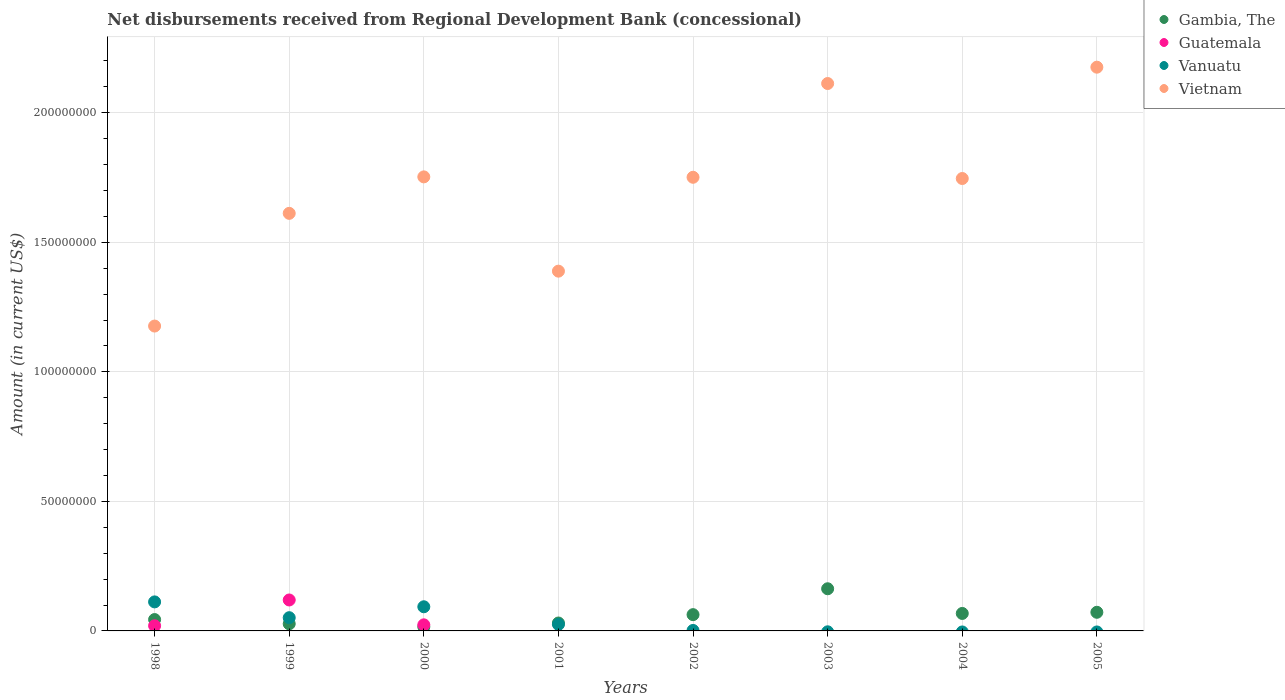What is the amount of disbursements received from Regional Development Bank in Vietnam in 1998?
Provide a short and direct response. 1.18e+08. Across all years, what is the maximum amount of disbursements received from Regional Development Bank in Gambia, The?
Your response must be concise. 1.63e+07. In which year was the amount of disbursements received from Regional Development Bank in Vietnam maximum?
Ensure brevity in your answer.  2005. What is the total amount of disbursements received from Regional Development Bank in Gambia, The in the graph?
Offer a very short reply. 4.83e+07. What is the difference between the amount of disbursements received from Regional Development Bank in Vietnam in 1998 and that in 2003?
Your answer should be very brief. -9.36e+07. What is the difference between the amount of disbursements received from Regional Development Bank in Vietnam in 2003 and the amount of disbursements received from Regional Development Bank in Guatemala in 1999?
Give a very brief answer. 1.99e+08. What is the average amount of disbursements received from Regional Development Bank in Vanuatu per year?
Your answer should be very brief. 3.54e+06. In the year 1999, what is the difference between the amount of disbursements received from Regional Development Bank in Vanuatu and amount of disbursements received from Regional Development Bank in Vietnam?
Ensure brevity in your answer.  -1.56e+08. In how many years, is the amount of disbursements received from Regional Development Bank in Vietnam greater than 160000000 US$?
Your answer should be compact. 6. What is the ratio of the amount of disbursements received from Regional Development Bank in Gambia, The in 2000 to that in 2003?
Your response must be concise. 0.1. Is the difference between the amount of disbursements received from Regional Development Bank in Vanuatu in 1998 and 1999 greater than the difference between the amount of disbursements received from Regional Development Bank in Vietnam in 1998 and 1999?
Your answer should be very brief. Yes. What is the difference between the highest and the second highest amount of disbursements received from Regional Development Bank in Vietnam?
Offer a terse response. 6.31e+06. What is the difference between the highest and the lowest amount of disbursements received from Regional Development Bank in Guatemala?
Your answer should be compact. 1.19e+07. In how many years, is the amount of disbursements received from Regional Development Bank in Vanuatu greater than the average amount of disbursements received from Regional Development Bank in Vanuatu taken over all years?
Your answer should be compact. 3. Is the amount of disbursements received from Regional Development Bank in Guatemala strictly greater than the amount of disbursements received from Regional Development Bank in Gambia, The over the years?
Give a very brief answer. No. How many dotlines are there?
Your answer should be very brief. 4. Are the values on the major ticks of Y-axis written in scientific E-notation?
Provide a short and direct response. No. Where does the legend appear in the graph?
Ensure brevity in your answer.  Top right. How many legend labels are there?
Your answer should be compact. 4. What is the title of the graph?
Your response must be concise. Net disbursements received from Regional Development Bank (concessional). Does "New Caledonia" appear as one of the legend labels in the graph?
Provide a succinct answer. No. What is the label or title of the X-axis?
Give a very brief answer. Years. What is the Amount (in current US$) in Gambia, The in 1998?
Keep it short and to the point. 4.39e+06. What is the Amount (in current US$) of Guatemala in 1998?
Your answer should be compact. 1.99e+06. What is the Amount (in current US$) in Vanuatu in 1998?
Keep it short and to the point. 1.12e+07. What is the Amount (in current US$) of Vietnam in 1998?
Your answer should be very brief. 1.18e+08. What is the Amount (in current US$) of Gambia, The in 1999?
Your answer should be very brief. 2.75e+06. What is the Amount (in current US$) in Guatemala in 1999?
Keep it short and to the point. 1.19e+07. What is the Amount (in current US$) of Vanuatu in 1999?
Provide a succinct answer. 5.10e+06. What is the Amount (in current US$) of Vietnam in 1999?
Ensure brevity in your answer.  1.61e+08. What is the Amount (in current US$) of Gambia, The in 2000?
Keep it short and to the point. 1.57e+06. What is the Amount (in current US$) of Guatemala in 2000?
Provide a short and direct response. 2.35e+06. What is the Amount (in current US$) in Vanuatu in 2000?
Offer a terse response. 9.32e+06. What is the Amount (in current US$) in Vietnam in 2000?
Provide a succinct answer. 1.75e+08. What is the Amount (in current US$) in Gambia, The in 2001?
Offer a terse response. 3.06e+06. What is the Amount (in current US$) of Vanuatu in 2001?
Offer a very short reply. 2.52e+06. What is the Amount (in current US$) in Vietnam in 2001?
Offer a very short reply. 1.39e+08. What is the Amount (in current US$) in Gambia, The in 2002?
Offer a very short reply. 6.28e+06. What is the Amount (in current US$) of Guatemala in 2002?
Offer a very short reply. 0. What is the Amount (in current US$) of Vanuatu in 2002?
Provide a succinct answer. 1.81e+05. What is the Amount (in current US$) in Vietnam in 2002?
Your response must be concise. 1.75e+08. What is the Amount (in current US$) in Gambia, The in 2003?
Your answer should be very brief. 1.63e+07. What is the Amount (in current US$) of Guatemala in 2003?
Provide a short and direct response. 0. What is the Amount (in current US$) in Vietnam in 2003?
Offer a terse response. 2.11e+08. What is the Amount (in current US$) of Gambia, The in 2004?
Give a very brief answer. 6.75e+06. What is the Amount (in current US$) in Vanuatu in 2004?
Your answer should be very brief. 0. What is the Amount (in current US$) of Vietnam in 2004?
Offer a terse response. 1.75e+08. What is the Amount (in current US$) in Gambia, The in 2005?
Offer a terse response. 7.19e+06. What is the Amount (in current US$) of Vanuatu in 2005?
Your answer should be very brief. 0. What is the Amount (in current US$) of Vietnam in 2005?
Your answer should be very brief. 2.18e+08. Across all years, what is the maximum Amount (in current US$) in Gambia, The?
Offer a very short reply. 1.63e+07. Across all years, what is the maximum Amount (in current US$) in Guatemala?
Your answer should be very brief. 1.19e+07. Across all years, what is the maximum Amount (in current US$) of Vanuatu?
Keep it short and to the point. 1.12e+07. Across all years, what is the maximum Amount (in current US$) in Vietnam?
Your response must be concise. 2.18e+08. Across all years, what is the minimum Amount (in current US$) of Gambia, The?
Provide a short and direct response. 1.57e+06. Across all years, what is the minimum Amount (in current US$) of Guatemala?
Keep it short and to the point. 0. Across all years, what is the minimum Amount (in current US$) in Vanuatu?
Keep it short and to the point. 0. Across all years, what is the minimum Amount (in current US$) of Vietnam?
Offer a terse response. 1.18e+08. What is the total Amount (in current US$) of Gambia, The in the graph?
Your answer should be very brief. 4.83e+07. What is the total Amount (in current US$) of Guatemala in the graph?
Give a very brief answer. 1.63e+07. What is the total Amount (in current US$) of Vanuatu in the graph?
Offer a terse response. 2.83e+07. What is the total Amount (in current US$) in Vietnam in the graph?
Ensure brevity in your answer.  1.37e+09. What is the difference between the Amount (in current US$) of Gambia, The in 1998 and that in 1999?
Offer a very short reply. 1.64e+06. What is the difference between the Amount (in current US$) of Guatemala in 1998 and that in 1999?
Provide a succinct answer. -9.95e+06. What is the difference between the Amount (in current US$) in Vanuatu in 1998 and that in 1999?
Offer a very short reply. 6.10e+06. What is the difference between the Amount (in current US$) in Vietnam in 1998 and that in 1999?
Offer a very short reply. -4.35e+07. What is the difference between the Amount (in current US$) of Gambia, The in 1998 and that in 2000?
Give a very brief answer. 2.82e+06. What is the difference between the Amount (in current US$) in Guatemala in 1998 and that in 2000?
Make the answer very short. -3.56e+05. What is the difference between the Amount (in current US$) of Vanuatu in 1998 and that in 2000?
Provide a succinct answer. 1.88e+06. What is the difference between the Amount (in current US$) of Vietnam in 1998 and that in 2000?
Provide a short and direct response. -5.76e+07. What is the difference between the Amount (in current US$) of Gambia, The in 1998 and that in 2001?
Provide a short and direct response. 1.33e+06. What is the difference between the Amount (in current US$) in Vanuatu in 1998 and that in 2001?
Your response must be concise. 8.68e+06. What is the difference between the Amount (in current US$) in Vietnam in 1998 and that in 2001?
Give a very brief answer. -2.12e+07. What is the difference between the Amount (in current US$) of Gambia, The in 1998 and that in 2002?
Offer a very short reply. -1.89e+06. What is the difference between the Amount (in current US$) in Vanuatu in 1998 and that in 2002?
Your answer should be very brief. 1.10e+07. What is the difference between the Amount (in current US$) in Vietnam in 1998 and that in 2002?
Provide a succinct answer. -5.74e+07. What is the difference between the Amount (in current US$) of Gambia, The in 1998 and that in 2003?
Keep it short and to the point. -1.19e+07. What is the difference between the Amount (in current US$) of Vietnam in 1998 and that in 2003?
Offer a very short reply. -9.36e+07. What is the difference between the Amount (in current US$) of Gambia, The in 1998 and that in 2004?
Your answer should be compact. -2.36e+06. What is the difference between the Amount (in current US$) in Vietnam in 1998 and that in 2004?
Your response must be concise. -5.70e+07. What is the difference between the Amount (in current US$) of Gambia, The in 1998 and that in 2005?
Make the answer very short. -2.80e+06. What is the difference between the Amount (in current US$) in Vietnam in 1998 and that in 2005?
Offer a terse response. -9.99e+07. What is the difference between the Amount (in current US$) of Gambia, The in 1999 and that in 2000?
Provide a succinct answer. 1.18e+06. What is the difference between the Amount (in current US$) in Guatemala in 1999 and that in 2000?
Your response must be concise. 9.60e+06. What is the difference between the Amount (in current US$) of Vanuatu in 1999 and that in 2000?
Give a very brief answer. -4.22e+06. What is the difference between the Amount (in current US$) in Vietnam in 1999 and that in 2000?
Provide a succinct answer. -1.41e+07. What is the difference between the Amount (in current US$) of Gambia, The in 1999 and that in 2001?
Make the answer very short. -3.10e+05. What is the difference between the Amount (in current US$) in Vanuatu in 1999 and that in 2001?
Keep it short and to the point. 2.58e+06. What is the difference between the Amount (in current US$) of Vietnam in 1999 and that in 2001?
Make the answer very short. 2.23e+07. What is the difference between the Amount (in current US$) in Gambia, The in 1999 and that in 2002?
Your answer should be very brief. -3.54e+06. What is the difference between the Amount (in current US$) of Vanuatu in 1999 and that in 2002?
Offer a terse response. 4.92e+06. What is the difference between the Amount (in current US$) in Vietnam in 1999 and that in 2002?
Your answer should be compact. -1.39e+07. What is the difference between the Amount (in current US$) in Gambia, The in 1999 and that in 2003?
Give a very brief answer. -1.35e+07. What is the difference between the Amount (in current US$) of Vietnam in 1999 and that in 2003?
Your answer should be very brief. -5.01e+07. What is the difference between the Amount (in current US$) of Gambia, The in 1999 and that in 2004?
Provide a succinct answer. -4.00e+06. What is the difference between the Amount (in current US$) in Vietnam in 1999 and that in 2004?
Provide a succinct answer. -1.34e+07. What is the difference between the Amount (in current US$) in Gambia, The in 1999 and that in 2005?
Keep it short and to the point. -4.45e+06. What is the difference between the Amount (in current US$) in Vietnam in 1999 and that in 2005?
Provide a succinct answer. -5.64e+07. What is the difference between the Amount (in current US$) of Gambia, The in 2000 and that in 2001?
Offer a very short reply. -1.48e+06. What is the difference between the Amount (in current US$) in Vanuatu in 2000 and that in 2001?
Make the answer very short. 6.80e+06. What is the difference between the Amount (in current US$) in Vietnam in 2000 and that in 2001?
Your answer should be very brief. 3.64e+07. What is the difference between the Amount (in current US$) of Gambia, The in 2000 and that in 2002?
Make the answer very short. -4.71e+06. What is the difference between the Amount (in current US$) in Vanuatu in 2000 and that in 2002?
Make the answer very short. 9.14e+06. What is the difference between the Amount (in current US$) of Vietnam in 2000 and that in 2002?
Make the answer very short. 1.56e+05. What is the difference between the Amount (in current US$) in Gambia, The in 2000 and that in 2003?
Make the answer very short. -1.47e+07. What is the difference between the Amount (in current US$) of Vietnam in 2000 and that in 2003?
Your answer should be compact. -3.60e+07. What is the difference between the Amount (in current US$) of Gambia, The in 2000 and that in 2004?
Offer a very short reply. -5.18e+06. What is the difference between the Amount (in current US$) in Vietnam in 2000 and that in 2004?
Offer a very short reply. 6.31e+05. What is the difference between the Amount (in current US$) of Gambia, The in 2000 and that in 2005?
Give a very brief answer. -5.62e+06. What is the difference between the Amount (in current US$) in Vietnam in 2000 and that in 2005?
Offer a terse response. -4.23e+07. What is the difference between the Amount (in current US$) in Gambia, The in 2001 and that in 2002?
Make the answer very short. -3.22e+06. What is the difference between the Amount (in current US$) in Vanuatu in 2001 and that in 2002?
Your response must be concise. 2.34e+06. What is the difference between the Amount (in current US$) in Vietnam in 2001 and that in 2002?
Make the answer very short. -3.62e+07. What is the difference between the Amount (in current US$) of Gambia, The in 2001 and that in 2003?
Ensure brevity in your answer.  -1.32e+07. What is the difference between the Amount (in current US$) in Vietnam in 2001 and that in 2003?
Make the answer very short. -7.24e+07. What is the difference between the Amount (in current US$) of Gambia, The in 2001 and that in 2004?
Your response must be concise. -3.69e+06. What is the difference between the Amount (in current US$) of Vietnam in 2001 and that in 2004?
Your answer should be compact. -3.58e+07. What is the difference between the Amount (in current US$) of Gambia, The in 2001 and that in 2005?
Offer a terse response. -4.14e+06. What is the difference between the Amount (in current US$) in Vietnam in 2001 and that in 2005?
Provide a succinct answer. -7.87e+07. What is the difference between the Amount (in current US$) in Gambia, The in 2002 and that in 2003?
Your response must be concise. -9.99e+06. What is the difference between the Amount (in current US$) of Vietnam in 2002 and that in 2003?
Provide a succinct answer. -3.62e+07. What is the difference between the Amount (in current US$) in Gambia, The in 2002 and that in 2004?
Keep it short and to the point. -4.66e+05. What is the difference between the Amount (in current US$) in Vietnam in 2002 and that in 2004?
Make the answer very short. 4.75e+05. What is the difference between the Amount (in current US$) in Gambia, The in 2002 and that in 2005?
Your answer should be compact. -9.11e+05. What is the difference between the Amount (in current US$) of Vietnam in 2002 and that in 2005?
Your answer should be very brief. -4.25e+07. What is the difference between the Amount (in current US$) in Gambia, The in 2003 and that in 2004?
Ensure brevity in your answer.  9.53e+06. What is the difference between the Amount (in current US$) in Vietnam in 2003 and that in 2004?
Offer a terse response. 3.67e+07. What is the difference between the Amount (in current US$) of Gambia, The in 2003 and that in 2005?
Your answer should be compact. 9.08e+06. What is the difference between the Amount (in current US$) of Vietnam in 2003 and that in 2005?
Ensure brevity in your answer.  -6.31e+06. What is the difference between the Amount (in current US$) in Gambia, The in 2004 and that in 2005?
Your answer should be compact. -4.45e+05. What is the difference between the Amount (in current US$) of Vietnam in 2004 and that in 2005?
Make the answer very short. -4.30e+07. What is the difference between the Amount (in current US$) in Gambia, The in 1998 and the Amount (in current US$) in Guatemala in 1999?
Make the answer very short. -7.56e+06. What is the difference between the Amount (in current US$) of Gambia, The in 1998 and the Amount (in current US$) of Vanuatu in 1999?
Ensure brevity in your answer.  -7.17e+05. What is the difference between the Amount (in current US$) in Gambia, The in 1998 and the Amount (in current US$) in Vietnam in 1999?
Ensure brevity in your answer.  -1.57e+08. What is the difference between the Amount (in current US$) of Guatemala in 1998 and the Amount (in current US$) of Vanuatu in 1999?
Your answer should be very brief. -3.11e+06. What is the difference between the Amount (in current US$) in Guatemala in 1998 and the Amount (in current US$) in Vietnam in 1999?
Keep it short and to the point. -1.59e+08. What is the difference between the Amount (in current US$) in Vanuatu in 1998 and the Amount (in current US$) in Vietnam in 1999?
Offer a terse response. -1.50e+08. What is the difference between the Amount (in current US$) of Gambia, The in 1998 and the Amount (in current US$) of Guatemala in 2000?
Ensure brevity in your answer.  2.04e+06. What is the difference between the Amount (in current US$) of Gambia, The in 1998 and the Amount (in current US$) of Vanuatu in 2000?
Offer a very short reply. -4.94e+06. What is the difference between the Amount (in current US$) in Gambia, The in 1998 and the Amount (in current US$) in Vietnam in 2000?
Your answer should be very brief. -1.71e+08. What is the difference between the Amount (in current US$) in Guatemala in 1998 and the Amount (in current US$) in Vanuatu in 2000?
Your answer should be very brief. -7.33e+06. What is the difference between the Amount (in current US$) in Guatemala in 1998 and the Amount (in current US$) in Vietnam in 2000?
Make the answer very short. -1.73e+08. What is the difference between the Amount (in current US$) in Vanuatu in 1998 and the Amount (in current US$) in Vietnam in 2000?
Your response must be concise. -1.64e+08. What is the difference between the Amount (in current US$) in Gambia, The in 1998 and the Amount (in current US$) in Vanuatu in 2001?
Your answer should be very brief. 1.86e+06. What is the difference between the Amount (in current US$) of Gambia, The in 1998 and the Amount (in current US$) of Vietnam in 2001?
Give a very brief answer. -1.34e+08. What is the difference between the Amount (in current US$) in Guatemala in 1998 and the Amount (in current US$) in Vanuatu in 2001?
Your answer should be compact. -5.31e+05. What is the difference between the Amount (in current US$) of Guatemala in 1998 and the Amount (in current US$) of Vietnam in 2001?
Your answer should be compact. -1.37e+08. What is the difference between the Amount (in current US$) of Vanuatu in 1998 and the Amount (in current US$) of Vietnam in 2001?
Offer a terse response. -1.28e+08. What is the difference between the Amount (in current US$) in Gambia, The in 1998 and the Amount (in current US$) in Vanuatu in 2002?
Your answer should be compact. 4.21e+06. What is the difference between the Amount (in current US$) in Gambia, The in 1998 and the Amount (in current US$) in Vietnam in 2002?
Offer a terse response. -1.71e+08. What is the difference between the Amount (in current US$) in Guatemala in 1998 and the Amount (in current US$) in Vanuatu in 2002?
Offer a very short reply. 1.81e+06. What is the difference between the Amount (in current US$) in Guatemala in 1998 and the Amount (in current US$) in Vietnam in 2002?
Make the answer very short. -1.73e+08. What is the difference between the Amount (in current US$) of Vanuatu in 1998 and the Amount (in current US$) of Vietnam in 2002?
Your answer should be very brief. -1.64e+08. What is the difference between the Amount (in current US$) of Gambia, The in 1998 and the Amount (in current US$) of Vietnam in 2003?
Your response must be concise. -2.07e+08. What is the difference between the Amount (in current US$) in Guatemala in 1998 and the Amount (in current US$) in Vietnam in 2003?
Ensure brevity in your answer.  -2.09e+08. What is the difference between the Amount (in current US$) in Vanuatu in 1998 and the Amount (in current US$) in Vietnam in 2003?
Your answer should be compact. -2.00e+08. What is the difference between the Amount (in current US$) of Gambia, The in 1998 and the Amount (in current US$) of Vietnam in 2004?
Make the answer very short. -1.70e+08. What is the difference between the Amount (in current US$) of Guatemala in 1998 and the Amount (in current US$) of Vietnam in 2004?
Ensure brevity in your answer.  -1.73e+08. What is the difference between the Amount (in current US$) in Vanuatu in 1998 and the Amount (in current US$) in Vietnam in 2004?
Offer a very short reply. -1.63e+08. What is the difference between the Amount (in current US$) of Gambia, The in 1998 and the Amount (in current US$) of Vietnam in 2005?
Give a very brief answer. -2.13e+08. What is the difference between the Amount (in current US$) of Guatemala in 1998 and the Amount (in current US$) of Vietnam in 2005?
Provide a short and direct response. -2.16e+08. What is the difference between the Amount (in current US$) of Vanuatu in 1998 and the Amount (in current US$) of Vietnam in 2005?
Make the answer very short. -2.06e+08. What is the difference between the Amount (in current US$) in Gambia, The in 1999 and the Amount (in current US$) in Guatemala in 2000?
Keep it short and to the point. 3.97e+05. What is the difference between the Amount (in current US$) in Gambia, The in 1999 and the Amount (in current US$) in Vanuatu in 2000?
Make the answer very short. -6.58e+06. What is the difference between the Amount (in current US$) of Gambia, The in 1999 and the Amount (in current US$) of Vietnam in 2000?
Your answer should be compact. -1.73e+08. What is the difference between the Amount (in current US$) in Guatemala in 1999 and the Amount (in current US$) in Vanuatu in 2000?
Your answer should be compact. 2.62e+06. What is the difference between the Amount (in current US$) in Guatemala in 1999 and the Amount (in current US$) in Vietnam in 2000?
Your answer should be compact. -1.63e+08. What is the difference between the Amount (in current US$) of Vanuatu in 1999 and the Amount (in current US$) of Vietnam in 2000?
Make the answer very short. -1.70e+08. What is the difference between the Amount (in current US$) in Gambia, The in 1999 and the Amount (in current US$) in Vanuatu in 2001?
Make the answer very short. 2.22e+05. What is the difference between the Amount (in current US$) in Gambia, The in 1999 and the Amount (in current US$) in Vietnam in 2001?
Offer a terse response. -1.36e+08. What is the difference between the Amount (in current US$) in Guatemala in 1999 and the Amount (in current US$) in Vanuatu in 2001?
Make the answer very short. 9.42e+06. What is the difference between the Amount (in current US$) in Guatemala in 1999 and the Amount (in current US$) in Vietnam in 2001?
Keep it short and to the point. -1.27e+08. What is the difference between the Amount (in current US$) of Vanuatu in 1999 and the Amount (in current US$) of Vietnam in 2001?
Give a very brief answer. -1.34e+08. What is the difference between the Amount (in current US$) of Gambia, The in 1999 and the Amount (in current US$) of Vanuatu in 2002?
Offer a very short reply. 2.56e+06. What is the difference between the Amount (in current US$) of Gambia, The in 1999 and the Amount (in current US$) of Vietnam in 2002?
Give a very brief answer. -1.72e+08. What is the difference between the Amount (in current US$) in Guatemala in 1999 and the Amount (in current US$) in Vanuatu in 2002?
Provide a short and direct response. 1.18e+07. What is the difference between the Amount (in current US$) of Guatemala in 1999 and the Amount (in current US$) of Vietnam in 2002?
Offer a very short reply. -1.63e+08. What is the difference between the Amount (in current US$) in Vanuatu in 1999 and the Amount (in current US$) in Vietnam in 2002?
Provide a short and direct response. -1.70e+08. What is the difference between the Amount (in current US$) of Gambia, The in 1999 and the Amount (in current US$) of Vietnam in 2003?
Ensure brevity in your answer.  -2.09e+08. What is the difference between the Amount (in current US$) in Guatemala in 1999 and the Amount (in current US$) in Vietnam in 2003?
Provide a succinct answer. -1.99e+08. What is the difference between the Amount (in current US$) in Vanuatu in 1999 and the Amount (in current US$) in Vietnam in 2003?
Your response must be concise. -2.06e+08. What is the difference between the Amount (in current US$) of Gambia, The in 1999 and the Amount (in current US$) of Vietnam in 2004?
Make the answer very short. -1.72e+08. What is the difference between the Amount (in current US$) in Guatemala in 1999 and the Amount (in current US$) in Vietnam in 2004?
Make the answer very short. -1.63e+08. What is the difference between the Amount (in current US$) in Vanuatu in 1999 and the Amount (in current US$) in Vietnam in 2004?
Make the answer very short. -1.70e+08. What is the difference between the Amount (in current US$) in Gambia, The in 1999 and the Amount (in current US$) in Vietnam in 2005?
Ensure brevity in your answer.  -2.15e+08. What is the difference between the Amount (in current US$) in Guatemala in 1999 and the Amount (in current US$) in Vietnam in 2005?
Your answer should be very brief. -2.06e+08. What is the difference between the Amount (in current US$) in Vanuatu in 1999 and the Amount (in current US$) in Vietnam in 2005?
Offer a terse response. -2.13e+08. What is the difference between the Amount (in current US$) of Gambia, The in 2000 and the Amount (in current US$) of Vanuatu in 2001?
Offer a terse response. -9.53e+05. What is the difference between the Amount (in current US$) of Gambia, The in 2000 and the Amount (in current US$) of Vietnam in 2001?
Your answer should be compact. -1.37e+08. What is the difference between the Amount (in current US$) in Guatemala in 2000 and the Amount (in current US$) in Vanuatu in 2001?
Keep it short and to the point. -1.75e+05. What is the difference between the Amount (in current US$) in Guatemala in 2000 and the Amount (in current US$) in Vietnam in 2001?
Your response must be concise. -1.37e+08. What is the difference between the Amount (in current US$) of Vanuatu in 2000 and the Amount (in current US$) of Vietnam in 2001?
Provide a succinct answer. -1.30e+08. What is the difference between the Amount (in current US$) in Gambia, The in 2000 and the Amount (in current US$) in Vanuatu in 2002?
Provide a succinct answer. 1.39e+06. What is the difference between the Amount (in current US$) in Gambia, The in 2000 and the Amount (in current US$) in Vietnam in 2002?
Give a very brief answer. -1.74e+08. What is the difference between the Amount (in current US$) in Guatemala in 2000 and the Amount (in current US$) in Vanuatu in 2002?
Keep it short and to the point. 2.17e+06. What is the difference between the Amount (in current US$) of Guatemala in 2000 and the Amount (in current US$) of Vietnam in 2002?
Offer a very short reply. -1.73e+08. What is the difference between the Amount (in current US$) in Vanuatu in 2000 and the Amount (in current US$) in Vietnam in 2002?
Your answer should be very brief. -1.66e+08. What is the difference between the Amount (in current US$) of Gambia, The in 2000 and the Amount (in current US$) of Vietnam in 2003?
Make the answer very short. -2.10e+08. What is the difference between the Amount (in current US$) in Guatemala in 2000 and the Amount (in current US$) in Vietnam in 2003?
Make the answer very short. -2.09e+08. What is the difference between the Amount (in current US$) of Vanuatu in 2000 and the Amount (in current US$) of Vietnam in 2003?
Your response must be concise. -2.02e+08. What is the difference between the Amount (in current US$) of Gambia, The in 2000 and the Amount (in current US$) of Vietnam in 2004?
Make the answer very short. -1.73e+08. What is the difference between the Amount (in current US$) of Guatemala in 2000 and the Amount (in current US$) of Vietnam in 2004?
Your response must be concise. -1.72e+08. What is the difference between the Amount (in current US$) in Vanuatu in 2000 and the Amount (in current US$) in Vietnam in 2004?
Ensure brevity in your answer.  -1.65e+08. What is the difference between the Amount (in current US$) in Gambia, The in 2000 and the Amount (in current US$) in Vietnam in 2005?
Offer a very short reply. -2.16e+08. What is the difference between the Amount (in current US$) of Guatemala in 2000 and the Amount (in current US$) of Vietnam in 2005?
Ensure brevity in your answer.  -2.15e+08. What is the difference between the Amount (in current US$) of Vanuatu in 2000 and the Amount (in current US$) of Vietnam in 2005?
Your answer should be very brief. -2.08e+08. What is the difference between the Amount (in current US$) of Gambia, The in 2001 and the Amount (in current US$) of Vanuatu in 2002?
Your answer should be very brief. 2.88e+06. What is the difference between the Amount (in current US$) of Gambia, The in 2001 and the Amount (in current US$) of Vietnam in 2002?
Keep it short and to the point. -1.72e+08. What is the difference between the Amount (in current US$) of Vanuatu in 2001 and the Amount (in current US$) of Vietnam in 2002?
Keep it short and to the point. -1.73e+08. What is the difference between the Amount (in current US$) in Gambia, The in 2001 and the Amount (in current US$) in Vietnam in 2003?
Keep it short and to the point. -2.08e+08. What is the difference between the Amount (in current US$) of Vanuatu in 2001 and the Amount (in current US$) of Vietnam in 2003?
Your answer should be very brief. -2.09e+08. What is the difference between the Amount (in current US$) in Gambia, The in 2001 and the Amount (in current US$) in Vietnam in 2004?
Make the answer very short. -1.72e+08. What is the difference between the Amount (in current US$) in Vanuatu in 2001 and the Amount (in current US$) in Vietnam in 2004?
Your answer should be compact. -1.72e+08. What is the difference between the Amount (in current US$) in Gambia, The in 2001 and the Amount (in current US$) in Vietnam in 2005?
Keep it short and to the point. -2.15e+08. What is the difference between the Amount (in current US$) in Vanuatu in 2001 and the Amount (in current US$) in Vietnam in 2005?
Make the answer very short. -2.15e+08. What is the difference between the Amount (in current US$) in Gambia, The in 2002 and the Amount (in current US$) in Vietnam in 2003?
Make the answer very short. -2.05e+08. What is the difference between the Amount (in current US$) in Vanuatu in 2002 and the Amount (in current US$) in Vietnam in 2003?
Your answer should be compact. -2.11e+08. What is the difference between the Amount (in current US$) in Gambia, The in 2002 and the Amount (in current US$) in Vietnam in 2004?
Make the answer very short. -1.68e+08. What is the difference between the Amount (in current US$) in Vanuatu in 2002 and the Amount (in current US$) in Vietnam in 2004?
Keep it short and to the point. -1.74e+08. What is the difference between the Amount (in current US$) in Gambia, The in 2002 and the Amount (in current US$) in Vietnam in 2005?
Provide a succinct answer. -2.11e+08. What is the difference between the Amount (in current US$) in Vanuatu in 2002 and the Amount (in current US$) in Vietnam in 2005?
Your answer should be very brief. -2.17e+08. What is the difference between the Amount (in current US$) in Gambia, The in 2003 and the Amount (in current US$) in Vietnam in 2004?
Offer a very short reply. -1.58e+08. What is the difference between the Amount (in current US$) in Gambia, The in 2003 and the Amount (in current US$) in Vietnam in 2005?
Offer a very short reply. -2.01e+08. What is the difference between the Amount (in current US$) in Gambia, The in 2004 and the Amount (in current US$) in Vietnam in 2005?
Offer a very short reply. -2.11e+08. What is the average Amount (in current US$) of Gambia, The per year?
Provide a succinct answer. 6.03e+06. What is the average Amount (in current US$) of Guatemala per year?
Give a very brief answer. 2.04e+06. What is the average Amount (in current US$) in Vanuatu per year?
Offer a very short reply. 3.54e+06. What is the average Amount (in current US$) of Vietnam per year?
Ensure brevity in your answer.  1.71e+08. In the year 1998, what is the difference between the Amount (in current US$) in Gambia, The and Amount (in current US$) in Guatemala?
Provide a short and direct response. 2.40e+06. In the year 1998, what is the difference between the Amount (in current US$) of Gambia, The and Amount (in current US$) of Vanuatu?
Ensure brevity in your answer.  -6.82e+06. In the year 1998, what is the difference between the Amount (in current US$) of Gambia, The and Amount (in current US$) of Vietnam?
Your response must be concise. -1.13e+08. In the year 1998, what is the difference between the Amount (in current US$) in Guatemala and Amount (in current US$) in Vanuatu?
Your answer should be compact. -9.21e+06. In the year 1998, what is the difference between the Amount (in current US$) in Guatemala and Amount (in current US$) in Vietnam?
Provide a short and direct response. -1.16e+08. In the year 1998, what is the difference between the Amount (in current US$) in Vanuatu and Amount (in current US$) in Vietnam?
Your response must be concise. -1.06e+08. In the year 1999, what is the difference between the Amount (in current US$) in Gambia, The and Amount (in current US$) in Guatemala?
Provide a short and direct response. -9.20e+06. In the year 1999, what is the difference between the Amount (in current US$) of Gambia, The and Amount (in current US$) of Vanuatu?
Give a very brief answer. -2.36e+06. In the year 1999, what is the difference between the Amount (in current US$) in Gambia, The and Amount (in current US$) in Vietnam?
Provide a short and direct response. -1.58e+08. In the year 1999, what is the difference between the Amount (in current US$) of Guatemala and Amount (in current US$) of Vanuatu?
Your answer should be very brief. 6.84e+06. In the year 1999, what is the difference between the Amount (in current US$) of Guatemala and Amount (in current US$) of Vietnam?
Ensure brevity in your answer.  -1.49e+08. In the year 1999, what is the difference between the Amount (in current US$) of Vanuatu and Amount (in current US$) of Vietnam?
Provide a short and direct response. -1.56e+08. In the year 2000, what is the difference between the Amount (in current US$) in Gambia, The and Amount (in current US$) in Guatemala?
Provide a succinct answer. -7.78e+05. In the year 2000, what is the difference between the Amount (in current US$) in Gambia, The and Amount (in current US$) in Vanuatu?
Offer a terse response. -7.75e+06. In the year 2000, what is the difference between the Amount (in current US$) of Gambia, The and Amount (in current US$) of Vietnam?
Provide a succinct answer. -1.74e+08. In the year 2000, what is the difference between the Amount (in current US$) in Guatemala and Amount (in current US$) in Vanuatu?
Your response must be concise. -6.98e+06. In the year 2000, what is the difference between the Amount (in current US$) of Guatemala and Amount (in current US$) of Vietnam?
Ensure brevity in your answer.  -1.73e+08. In the year 2000, what is the difference between the Amount (in current US$) in Vanuatu and Amount (in current US$) in Vietnam?
Your answer should be very brief. -1.66e+08. In the year 2001, what is the difference between the Amount (in current US$) of Gambia, The and Amount (in current US$) of Vanuatu?
Give a very brief answer. 5.32e+05. In the year 2001, what is the difference between the Amount (in current US$) of Gambia, The and Amount (in current US$) of Vietnam?
Offer a terse response. -1.36e+08. In the year 2001, what is the difference between the Amount (in current US$) of Vanuatu and Amount (in current US$) of Vietnam?
Provide a short and direct response. -1.36e+08. In the year 2002, what is the difference between the Amount (in current US$) in Gambia, The and Amount (in current US$) in Vanuatu?
Provide a succinct answer. 6.10e+06. In the year 2002, what is the difference between the Amount (in current US$) in Gambia, The and Amount (in current US$) in Vietnam?
Offer a very short reply. -1.69e+08. In the year 2002, what is the difference between the Amount (in current US$) of Vanuatu and Amount (in current US$) of Vietnam?
Make the answer very short. -1.75e+08. In the year 2003, what is the difference between the Amount (in current US$) of Gambia, The and Amount (in current US$) of Vietnam?
Keep it short and to the point. -1.95e+08. In the year 2004, what is the difference between the Amount (in current US$) of Gambia, The and Amount (in current US$) of Vietnam?
Keep it short and to the point. -1.68e+08. In the year 2005, what is the difference between the Amount (in current US$) of Gambia, The and Amount (in current US$) of Vietnam?
Offer a very short reply. -2.10e+08. What is the ratio of the Amount (in current US$) in Gambia, The in 1998 to that in 1999?
Offer a terse response. 1.6. What is the ratio of the Amount (in current US$) of Guatemala in 1998 to that in 1999?
Ensure brevity in your answer.  0.17. What is the ratio of the Amount (in current US$) of Vanuatu in 1998 to that in 1999?
Give a very brief answer. 2.19. What is the ratio of the Amount (in current US$) in Vietnam in 1998 to that in 1999?
Your response must be concise. 0.73. What is the ratio of the Amount (in current US$) of Gambia, The in 1998 to that in 2000?
Your answer should be compact. 2.79. What is the ratio of the Amount (in current US$) of Guatemala in 1998 to that in 2000?
Your answer should be compact. 0.85. What is the ratio of the Amount (in current US$) in Vanuatu in 1998 to that in 2000?
Keep it short and to the point. 1.2. What is the ratio of the Amount (in current US$) of Vietnam in 1998 to that in 2000?
Offer a very short reply. 0.67. What is the ratio of the Amount (in current US$) in Gambia, The in 1998 to that in 2001?
Offer a very short reply. 1.44. What is the ratio of the Amount (in current US$) in Vanuatu in 1998 to that in 2001?
Give a very brief answer. 4.44. What is the ratio of the Amount (in current US$) of Vietnam in 1998 to that in 2001?
Offer a very short reply. 0.85. What is the ratio of the Amount (in current US$) in Gambia, The in 1998 to that in 2002?
Your answer should be compact. 0.7. What is the ratio of the Amount (in current US$) of Vanuatu in 1998 to that in 2002?
Provide a succinct answer. 61.9. What is the ratio of the Amount (in current US$) in Vietnam in 1998 to that in 2002?
Offer a very short reply. 0.67. What is the ratio of the Amount (in current US$) in Gambia, The in 1998 to that in 2003?
Your response must be concise. 0.27. What is the ratio of the Amount (in current US$) of Vietnam in 1998 to that in 2003?
Make the answer very short. 0.56. What is the ratio of the Amount (in current US$) of Gambia, The in 1998 to that in 2004?
Ensure brevity in your answer.  0.65. What is the ratio of the Amount (in current US$) of Vietnam in 1998 to that in 2004?
Your answer should be compact. 0.67. What is the ratio of the Amount (in current US$) of Gambia, The in 1998 to that in 2005?
Make the answer very short. 0.61. What is the ratio of the Amount (in current US$) of Vietnam in 1998 to that in 2005?
Provide a succinct answer. 0.54. What is the ratio of the Amount (in current US$) in Gambia, The in 1999 to that in 2000?
Provide a succinct answer. 1.75. What is the ratio of the Amount (in current US$) in Guatemala in 1999 to that in 2000?
Provide a succinct answer. 5.08. What is the ratio of the Amount (in current US$) of Vanuatu in 1999 to that in 2000?
Make the answer very short. 0.55. What is the ratio of the Amount (in current US$) of Vietnam in 1999 to that in 2000?
Offer a terse response. 0.92. What is the ratio of the Amount (in current US$) of Gambia, The in 1999 to that in 2001?
Your answer should be very brief. 0.9. What is the ratio of the Amount (in current US$) in Vanuatu in 1999 to that in 2001?
Provide a succinct answer. 2.02. What is the ratio of the Amount (in current US$) in Vietnam in 1999 to that in 2001?
Your answer should be compact. 1.16. What is the ratio of the Amount (in current US$) in Gambia, The in 1999 to that in 2002?
Give a very brief answer. 0.44. What is the ratio of the Amount (in current US$) in Vanuatu in 1999 to that in 2002?
Your answer should be very brief. 28.2. What is the ratio of the Amount (in current US$) of Vietnam in 1999 to that in 2002?
Provide a short and direct response. 0.92. What is the ratio of the Amount (in current US$) of Gambia, The in 1999 to that in 2003?
Provide a short and direct response. 0.17. What is the ratio of the Amount (in current US$) of Vietnam in 1999 to that in 2003?
Ensure brevity in your answer.  0.76. What is the ratio of the Amount (in current US$) in Gambia, The in 1999 to that in 2004?
Ensure brevity in your answer.  0.41. What is the ratio of the Amount (in current US$) in Vietnam in 1999 to that in 2004?
Provide a succinct answer. 0.92. What is the ratio of the Amount (in current US$) in Gambia, The in 1999 to that in 2005?
Keep it short and to the point. 0.38. What is the ratio of the Amount (in current US$) of Vietnam in 1999 to that in 2005?
Provide a short and direct response. 0.74. What is the ratio of the Amount (in current US$) in Gambia, The in 2000 to that in 2001?
Offer a terse response. 0.51. What is the ratio of the Amount (in current US$) in Vanuatu in 2000 to that in 2001?
Make the answer very short. 3.69. What is the ratio of the Amount (in current US$) in Vietnam in 2000 to that in 2001?
Your response must be concise. 1.26. What is the ratio of the Amount (in current US$) in Gambia, The in 2000 to that in 2002?
Keep it short and to the point. 0.25. What is the ratio of the Amount (in current US$) in Vanuatu in 2000 to that in 2002?
Provide a succinct answer. 51.51. What is the ratio of the Amount (in current US$) in Gambia, The in 2000 to that in 2003?
Your response must be concise. 0.1. What is the ratio of the Amount (in current US$) of Vietnam in 2000 to that in 2003?
Provide a succinct answer. 0.83. What is the ratio of the Amount (in current US$) of Gambia, The in 2000 to that in 2004?
Your response must be concise. 0.23. What is the ratio of the Amount (in current US$) of Vietnam in 2000 to that in 2004?
Make the answer very short. 1. What is the ratio of the Amount (in current US$) in Gambia, The in 2000 to that in 2005?
Make the answer very short. 0.22. What is the ratio of the Amount (in current US$) in Vietnam in 2000 to that in 2005?
Keep it short and to the point. 0.81. What is the ratio of the Amount (in current US$) in Gambia, The in 2001 to that in 2002?
Your response must be concise. 0.49. What is the ratio of the Amount (in current US$) in Vanuatu in 2001 to that in 2002?
Your answer should be very brief. 13.94. What is the ratio of the Amount (in current US$) of Vietnam in 2001 to that in 2002?
Your answer should be compact. 0.79. What is the ratio of the Amount (in current US$) of Gambia, The in 2001 to that in 2003?
Ensure brevity in your answer.  0.19. What is the ratio of the Amount (in current US$) in Vietnam in 2001 to that in 2003?
Provide a short and direct response. 0.66. What is the ratio of the Amount (in current US$) in Gambia, The in 2001 to that in 2004?
Keep it short and to the point. 0.45. What is the ratio of the Amount (in current US$) in Vietnam in 2001 to that in 2004?
Ensure brevity in your answer.  0.8. What is the ratio of the Amount (in current US$) of Gambia, The in 2001 to that in 2005?
Provide a succinct answer. 0.42. What is the ratio of the Amount (in current US$) in Vietnam in 2001 to that in 2005?
Ensure brevity in your answer.  0.64. What is the ratio of the Amount (in current US$) in Gambia, The in 2002 to that in 2003?
Your response must be concise. 0.39. What is the ratio of the Amount (in current US$) in Vietnam in 2002 to that in 2003?
Ensure brevity in your answer.  0.83. What is the ratio of the Amount (in current US$) of Gambia, The in 2002 to that in 2004?
Offer a very short reply. 0.93. What is the ratio of the Amount (in current US$) of Vietnam in 2002 to that in 2004?
Your response must be concise. 1. What is the ratio of the Amount (in current US$) of Gambia, The in 2002 to that in 2005?
Offer a very short reply. 0.87. What is the ratio of the Amount (in current US$) of Vietnam in 2002 to that in 2005?
Your answer should be compact. 0.8. What is the ratio of the Amount (in current US$) in Gambia, The in 2003 to that in 2004?
Give a very brief answer. 2.41. What is the ratio of the Amount (in current US$) of Vietnam in 2003 to that in 2004?
Provide a short and direct response. 1.21. What is the ratio of the Amount (in current US$) of Gambia, The in 2003 to that in 2005?
Your answer should be compact. 2.26. What is the ratio of the Amount (in current US$) in Gambia, The in 2004 to that in 2005?
Make the answer very short. 0.94. What is the ratio of the Amount (in current US$) of Vietnam in 2004 to that in 2005?
Your response must be concise. 0.8. What is the difference between the highest and the second highest Amount (in current US$) in Gambia, The?
Keep it short and to the point. 9.08e+06. What is the difference between the highest and the second highest Amount (in current US$) of Guatemala?
Ensure brevity in your answer.  9.60e+06. What is the difference between the highest and the second highest Amount (in current US$) in Vanuatu?
Keep it short and to the point. 1.88e+06. What is the difference between the highest and the second highest Amount (in current US$) of Vietnam?
Keep it short and to the point. 6.31e+06. What is the difference between the highest and the lowest Amount (in current US$) in Gambia, The?
Offer a very short reply. 1.47e+07. What is the difference between the highest and the lowest Amount (in current US$) of Guatemala?
Keep it short and to the point. 1.19e+07. What is the difference between the highest and the lowest Amount (in current US$) of Vanuatu?
Offer a very short reply. 1.12e+07. What is the difference between the highest and the lowest Amount (in current US$) of Vietnam?
Give a very brief answer. 9.99e+07. 